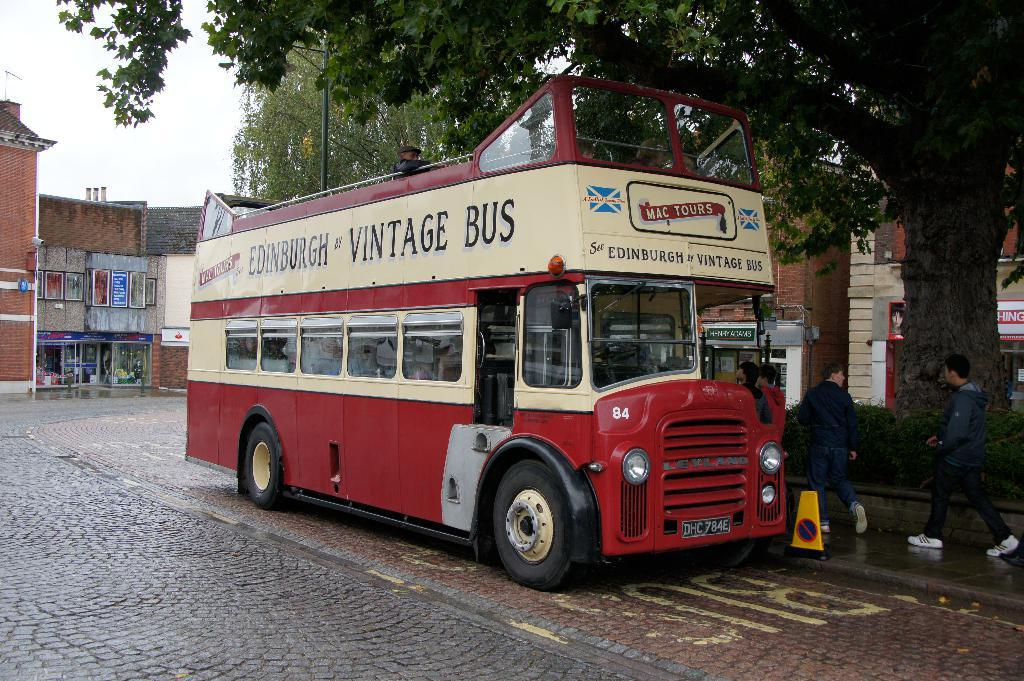<image>
Render a clear and concise summary of the photo. Red and white double decker bus which says VINTAGE BUS on it. 